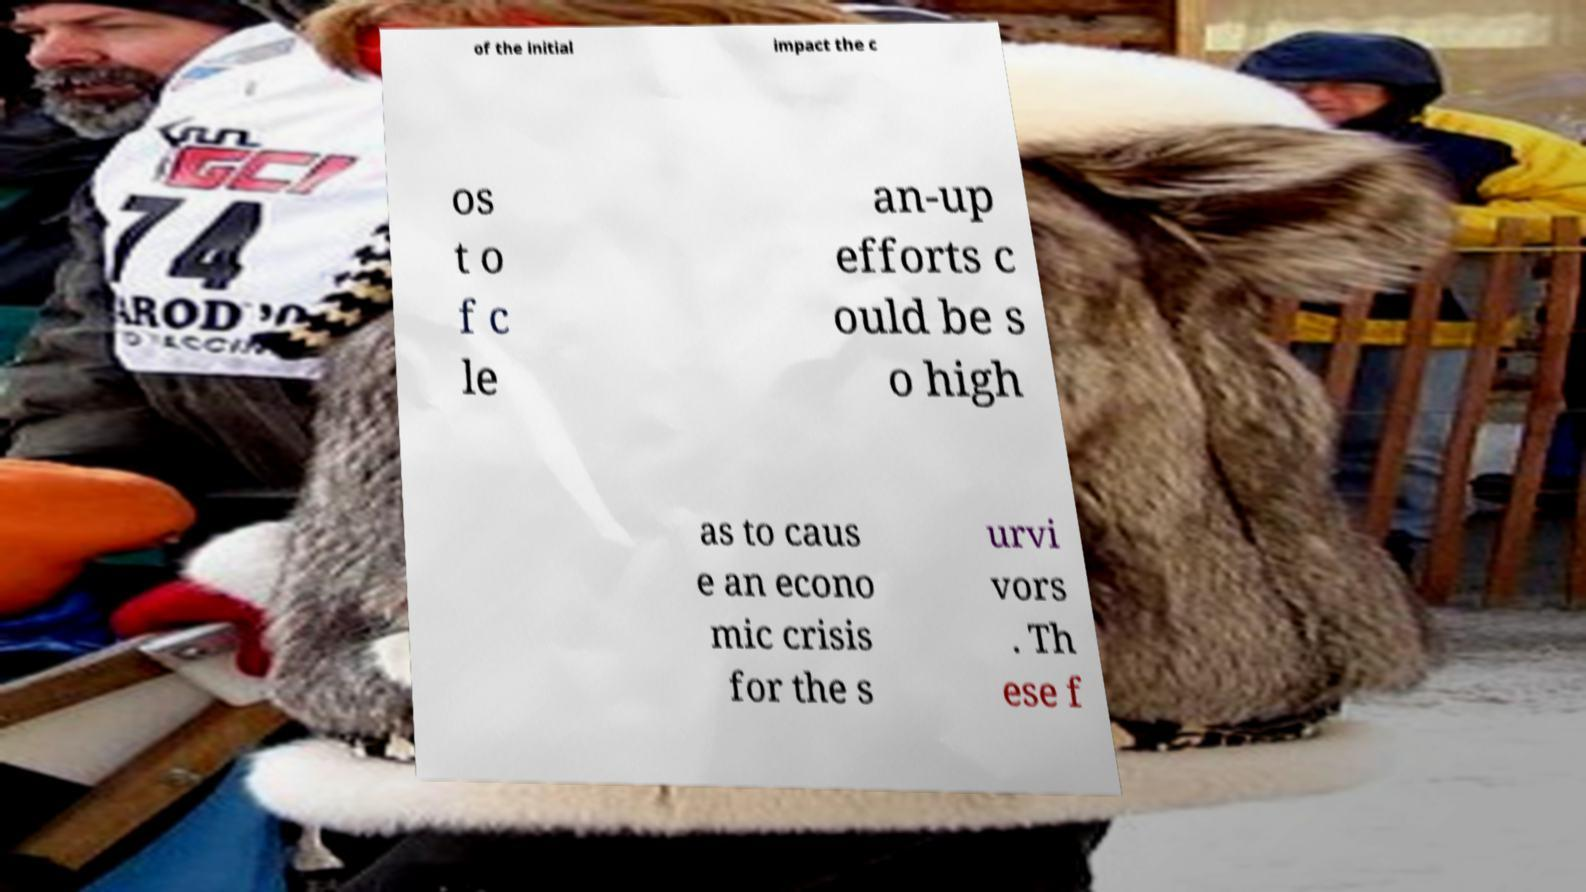I need the written content from this picture converted into text. Can you do that? of the initial impact the c os t o f c le an-up efforts c ould be s o high as to caus e an econo mic crisis for the s urvi vors . Th ese f 